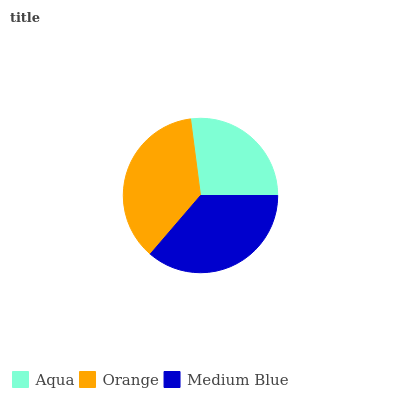Is Aqua the minimum?
Answer yes or no. Yes. Is Orange the maximum?
Answer yes or no. Yes. Is Medium Blue the minimum?
Answer yes or no. No. Is Medium Blue the maximum?
Answer yes or no. No. Is Orange greater than Medium Blue?
Answer yes or no. Yes. Is Medium Blue less than Orange?
Answer yes or no. Yes. Is Medium Blue greater than Orange?
Answer yes or no. No. Is Orange less than Medium Blue?
Answer yes or no. No. Is Medium Blue the high median?
Answer yes or no. Yes. Is Medium Blue the low median?
Answer yes or no. Yes. Is Aqua the high median?
Answer yes or no. No. Is Aqua the low median?
Answer yes or no. No. 